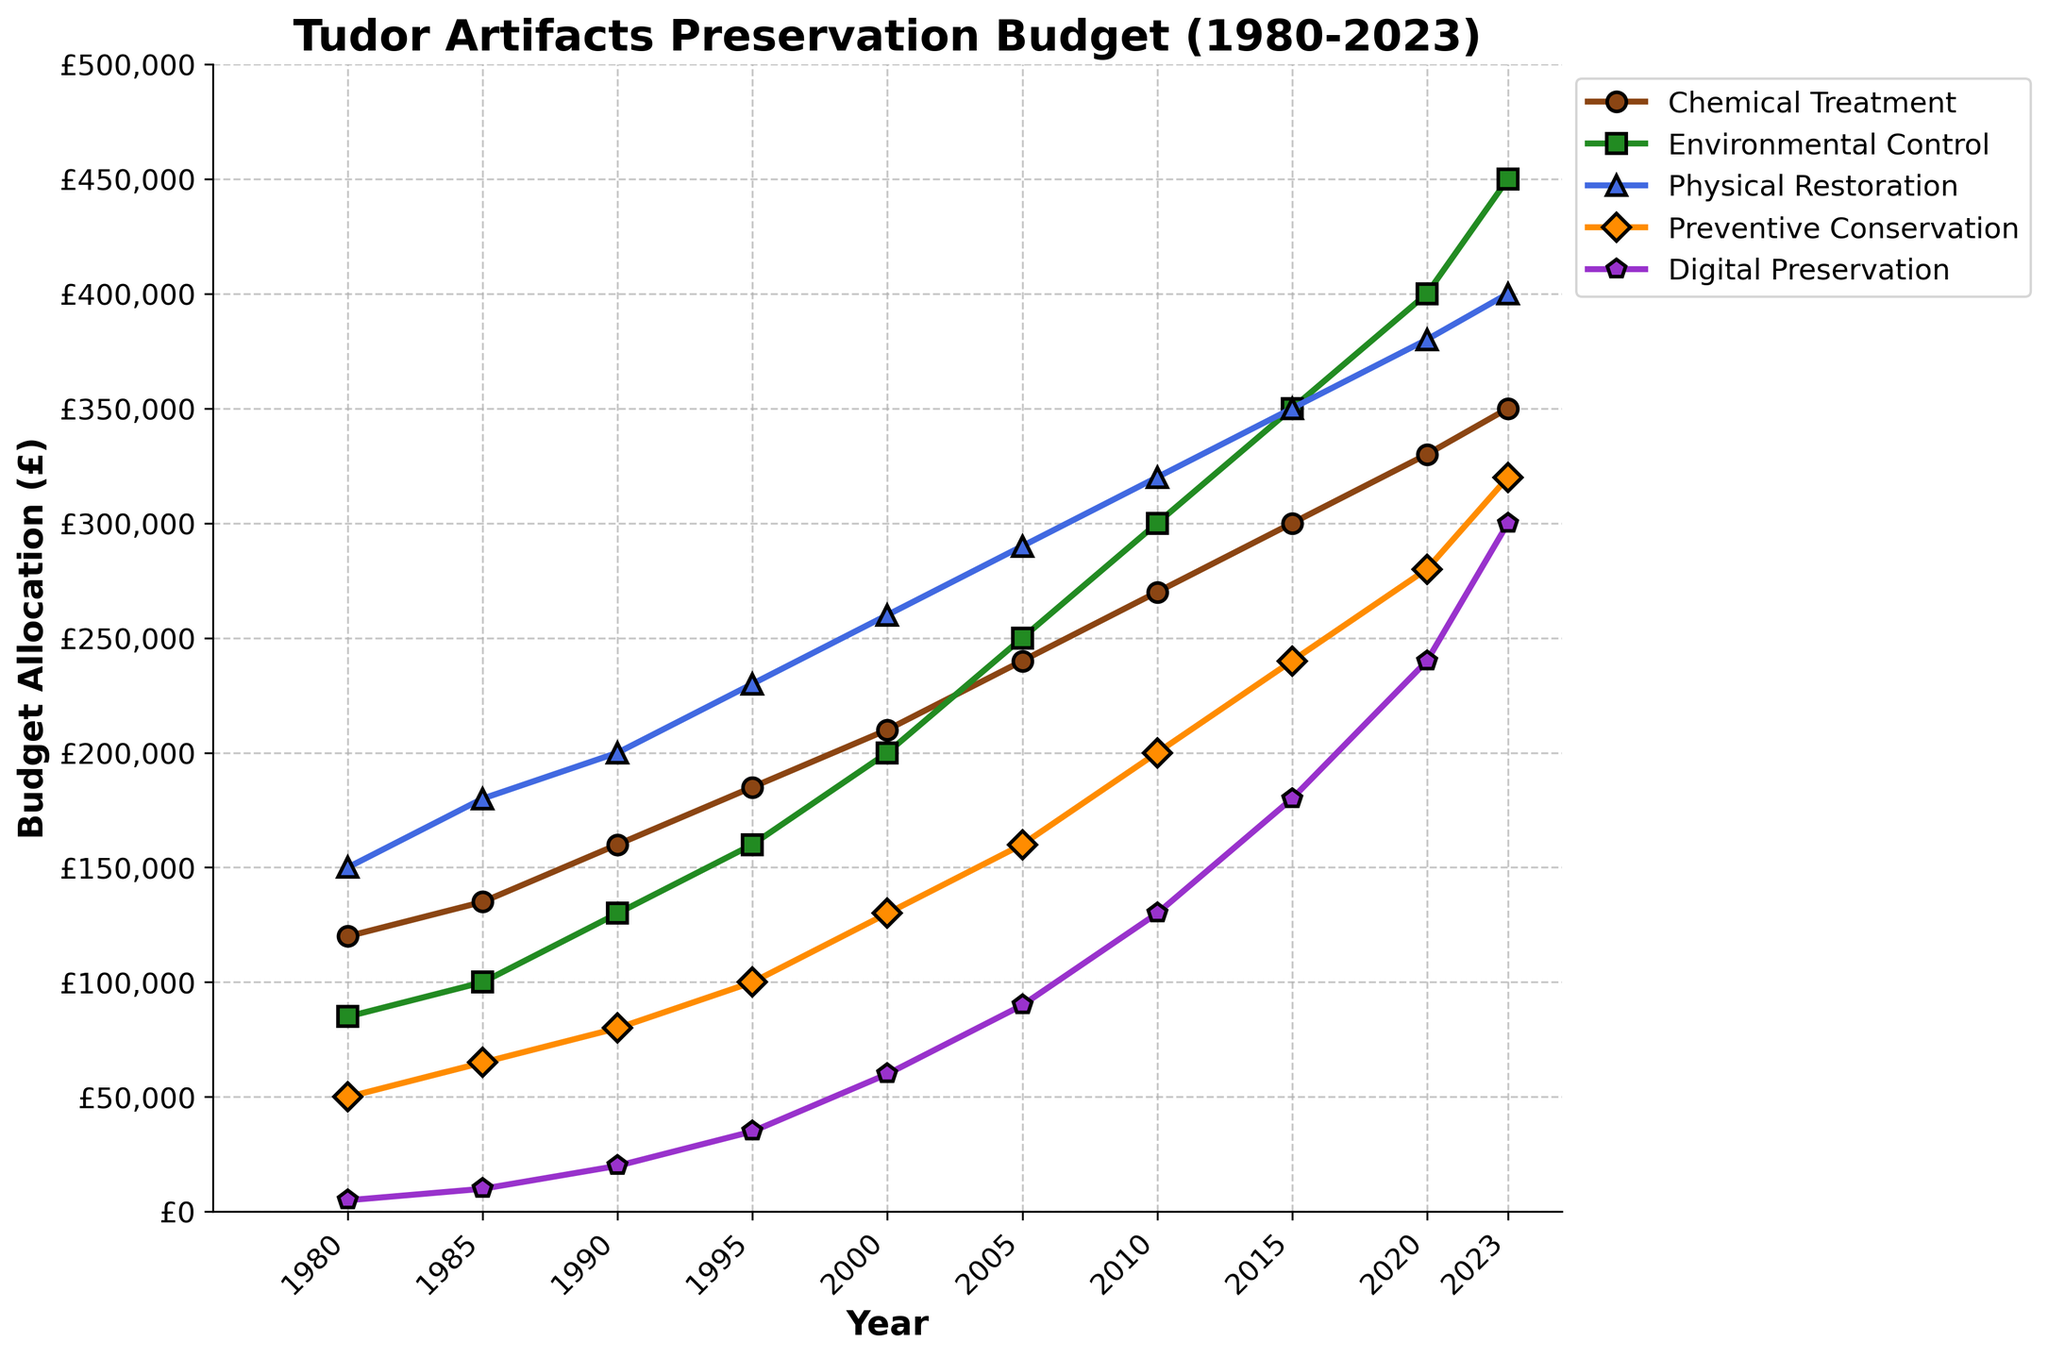What was the highest budget allocation in 1980 and for which technique? In the figure, look at the values for each technique for the year 1980. The highest value is 150,000 for Physical Restoration.
Answer: £150,000 for Physical Restoration How has the budget for Digital Preservation changed from 1980 to 2023? In the figure, compare the values for Digital Preservation in 1980 and 2023. The value increases from 5,000 in 1980 to 300,000 in 2023.
Answer: Increased by £295,000 Which conservation technique saw the largest increase in budget allocation between 1980 and 2023? Compare the increases in budget from 1980 to 2023 for each technique. Environmental Control increased from 85,000 to 450,000, which is an increase of 365,000, the largest among the techniques.
Answer: Environmental Control What is the total budget allocation for all techniques in 1990? Sum the budget allocations for all five techniques in 1990: 160,000 + 130,000 + 200,000 + 80,000 + 20,000 = 590,000.
Answer: £590,000 In which year did Preventive Conservation reach a budget of 200,000? Look at the budget allocations for Preventive Conservation over the years. The budget reaches 200,000 in the year 2010.
Answer: 2010 How does the trend of Physical Restoration budget allocation compare to Chemical Treatment from 1980 to 2023? Observe the overall trend in budget allocations for both techniques. Physical Restoration consistently has higher budgets than Chemical Treatment from 1980 to 2023, though both show a steady increase over time.
Answer: Physical Restoration consistently higher Between 2000 and 2010, which technique had the steepest budget increase? Compare the budget increases for each technique from 2000 to 2010. Environmental Control rose from 200,000 in 2000 to 300,000 in 2010, an increase of 100,000, which is the steepest increase.
Answer: Environmental Control What was the average budget allocation for Preventive Conservation across all years? Sum the budget allocations for Preventive Conservation and divide by the number of years: (50,000 + 65,000 + 80,000 + 100,000 + 130,000 + 160,000 + 200,000 + 240,000 + 280,000 + 320,000) / 10 = 162,500.
Answer: £162,500 Is there any year when the budget for Chemical Treatment surpassed 300,000? Examine the budget allocations for Chemical Treatment for all years. The highest allocation is in 2023, reaching 350,000, which is above 300,000.
Answer: Yes, in 2023 How does the budget allocation in 2023 compare to 1980 for Preventive Conservation and Physical Restoration? Compare the values for these two techniques in 2023 and 1980. Preventive Conservation increased from 50,000 to 320,000 (an increase of 270,000), and Physical Restoration went from 150,000 to 400,000 (an increase of 250,000).
Answer: Preventive Conservation +270,000, Physical Restoration +250,000 